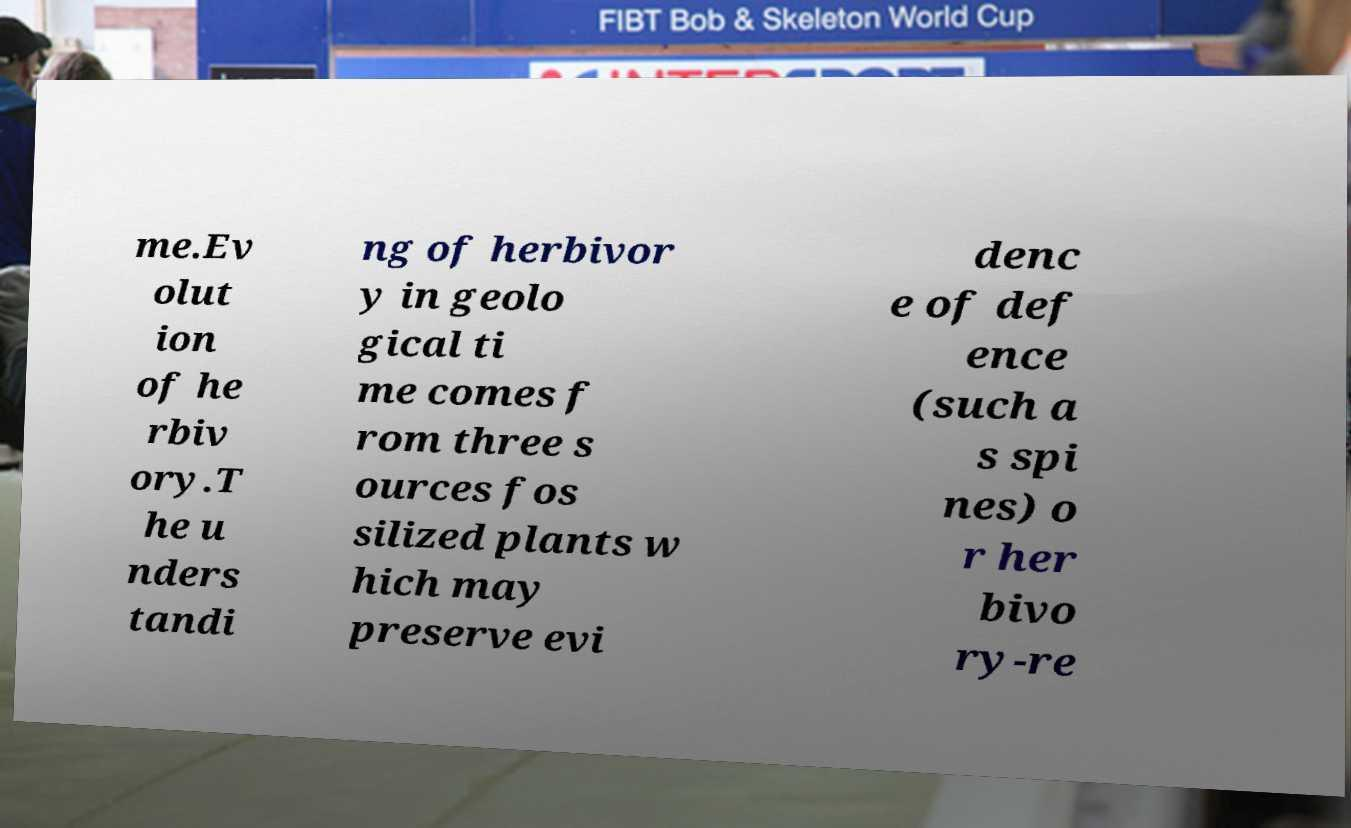What messages or text are displayed in this image? I need them in a readable, typed format. me.Ev olut ion of he rbiv ory.T he u nders tandi ng of herbivor y in geolo gical ti me comes f rom three s ources fos silized plants w hich may preserve evi denc e of def ence (such a s spi nes) o r her bivo ry-re 